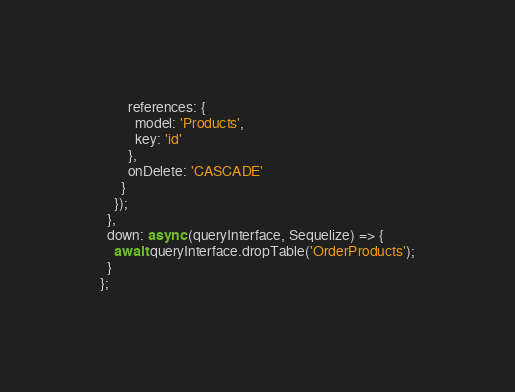<code> <loc_0><loc_0><loc_500><loc_500><_JavaScript_>        references: {
          model: 'Products',
          key: 'id'
        },
        onDelete: 'CASCADE'
      }
    });
  },
  down: async (queryInterface, Sequelize) => {
    await queryInterface.dropTable('OrderProducts');
  }
};</code> 